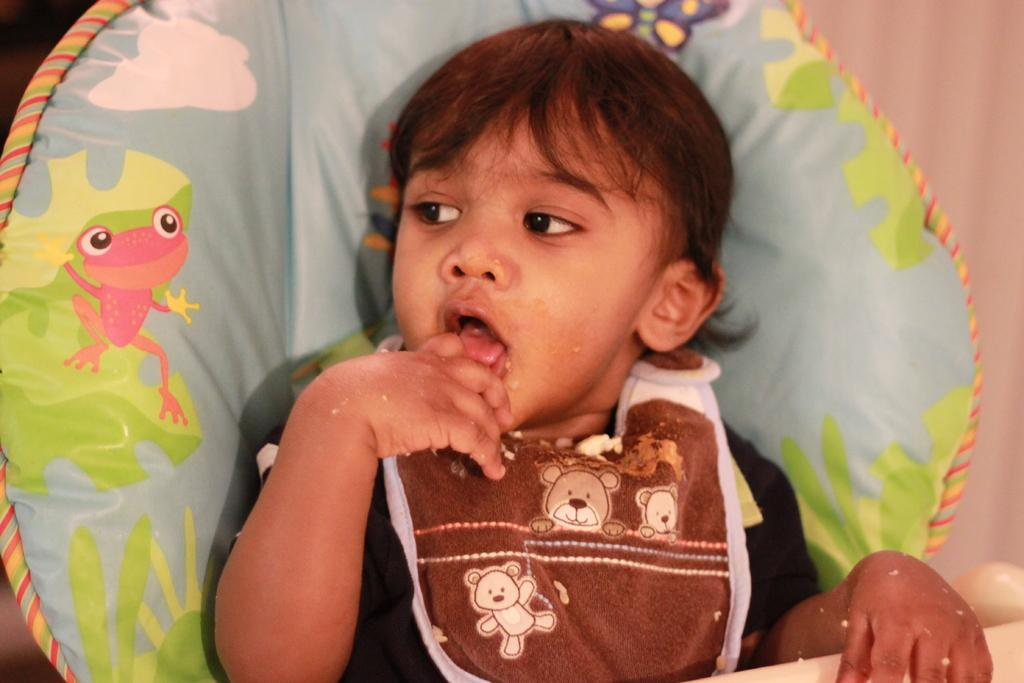Who is present in the image? There is a girl in the image. What is the girl wearing? The girl is wearing clothes. What can be seen in the background of the image? There is an object with cartoon images in the background of the image. Reasoning: Let' Let's think step by step in order to produce the conversation. We start by identifying the main subject in the image, which is the girl. Then, we describe what the girl is wearing, as it is mentioned in the facts. Finally, we mention the object with cartoon images in the background, which adds more detail to the image's description. Absurd Question/Answer: What type of beast can be seen interacting with the girl in the image? There is no beast present in the image; it only features a girl and an object with cartoon images in the background. How many cats are visible in the image? There are no cats present in the image. What type of beast can be seen interacting with the girl in the image? There is no beast present in the image; it only features a girl and an object with cartoon images in the background. How many cats are visible in the image? There are no cats present in the image. --- Facts: 1. There is a car in the image. 2. The car is red. 3. The car has four wheels. 4. There is a road in the image. 5. The road is paved. Absurd Topics: bird, ocean, mountain Conversation: What is the main subject of the image? The main subject of the image is a car. What color is the car? The car is red. How many wheels does the car have? The car has four wheels. What can be seen in the background of the image? There is a road in the image. What type of road is visible in the image? The road is paved. Reasoning: Let's think step by step in order to produce the conversation. We start by identifying the main subject in the image, which is the car. Then, we describe the car's color and the number of wheels it has, as they are mentioned in the facts. Finally, we mention the road in the 